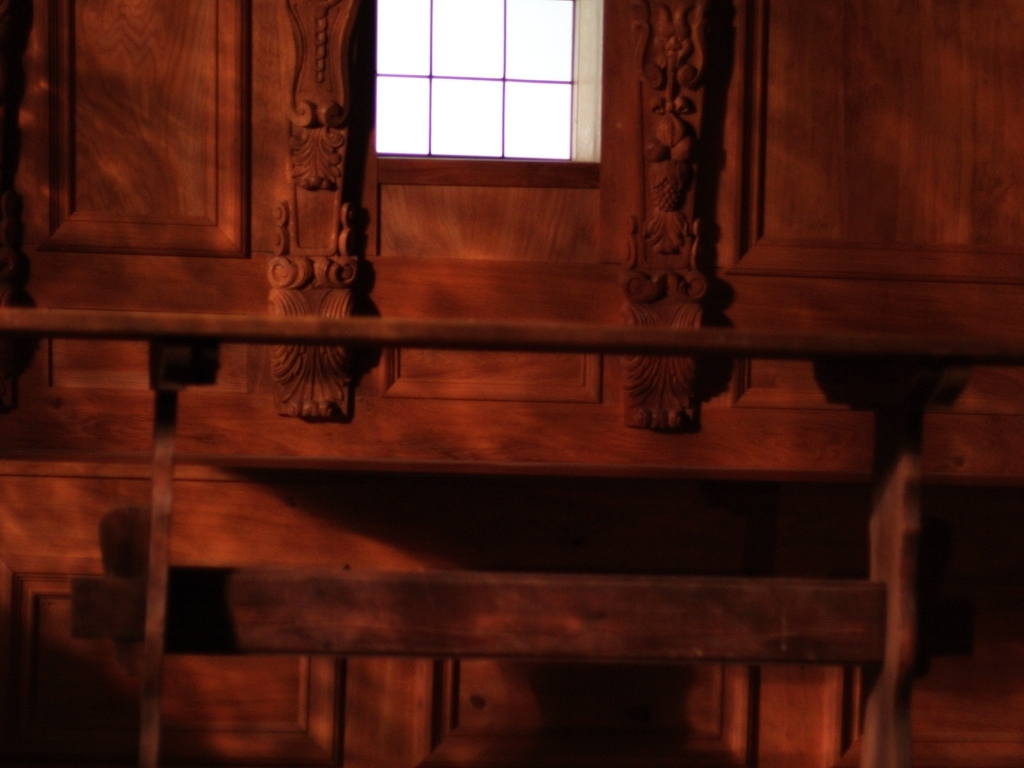What could be the function of this room, based on its appearance? With its grand wooden details and robust furniture, this room may have served a formal purpose, like a dining hall or meeting room in a period-specific environment. 